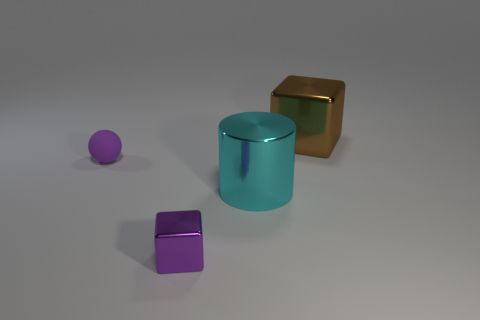Add 2 yellow cubes. How many objects exist? 6 Subtract all brown cylinders. Subtract all yellow balls. How many cylinders are left? 1 Subtract all cylinders. How many objects are left? 3 Subtract 0 green cylinders. How many objects are left? 4 Subtract all small matte things. Subtract all small green balls. How many objects are left? 3 Add 3 tiny purple spheres. How many tiny purple spheres are left? 4 Add 2 tiny rubber spheres. How many tiny rubber spheres exist? 3 